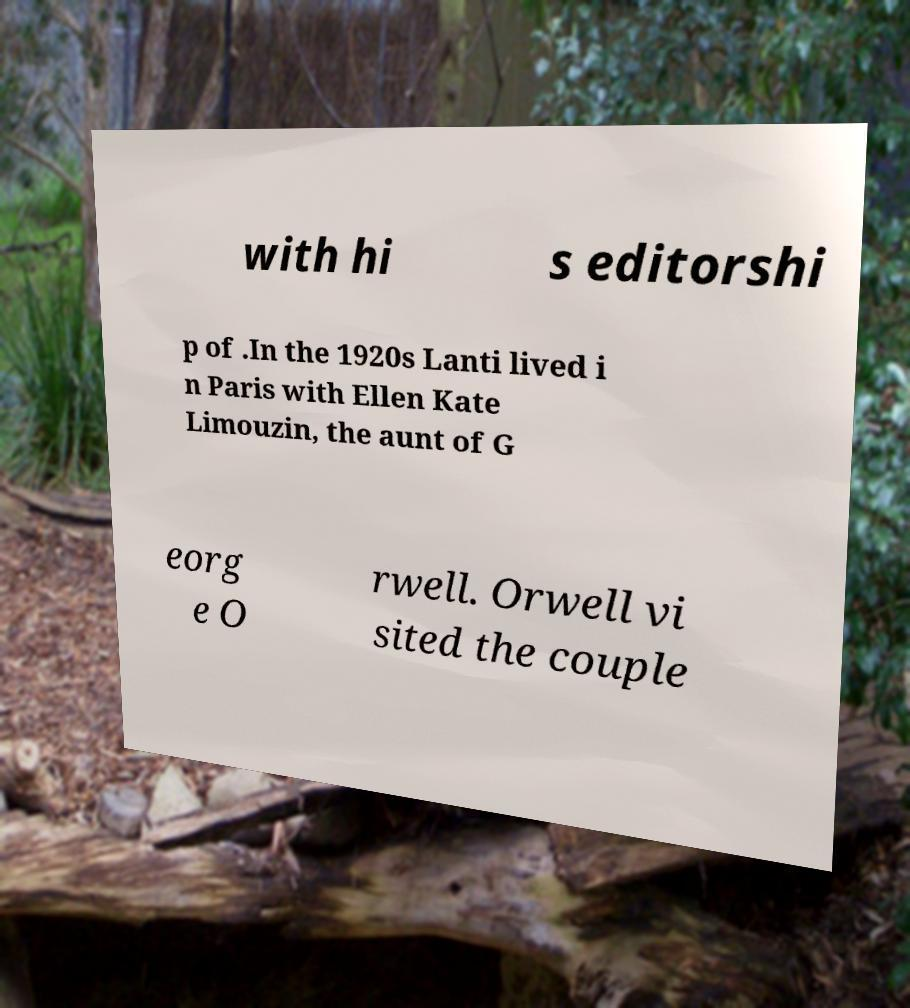I need the written content from this picture converted into text. Can you do that? with hi s editorshi p of .In the 1920s Lanti lived i n Paris with Ellen Kate Limouzin, the aunt of G eorg e O rwell. Orwell vi sited the couple 